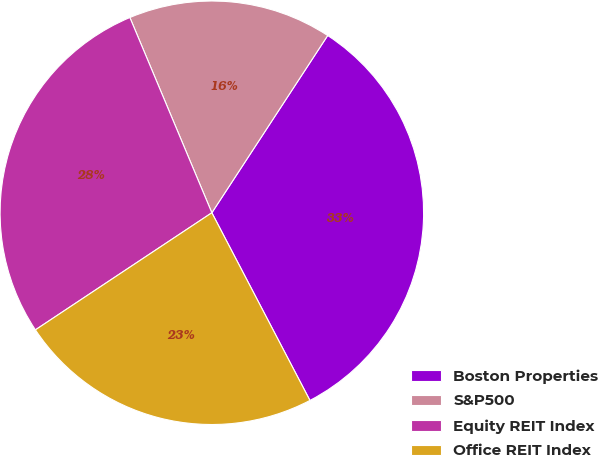Convert chart. <chart><loc_0><loc_0><loc_500><loc_500><pie_chart><fcel>Boston Properties<fcel>S&P500<fcel>Equity REIT Index<fcel>Office REIT Index<nl><fcel>33.12%<fcel>15.54%<fcel>28.0%<fcel>23.34%<nl></chart> 